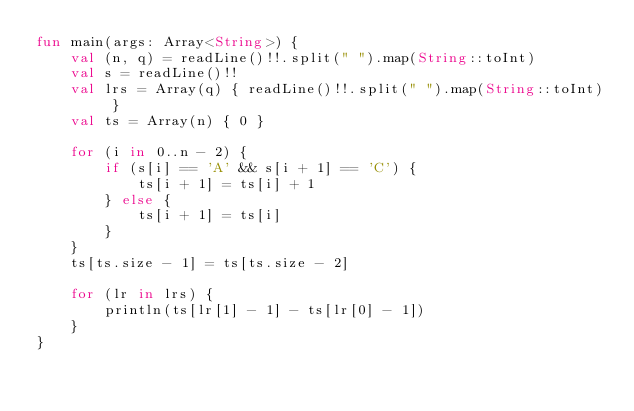Convert code to text. <code><loc_0><loc_0><loc_500><loc_500><_Kotlin_>fun main(args: Array<String>) {
    val (n, q) = readLine()!!.split(" ").map(String::toInt)
    val s = readLine()!!
    val lrs = Array(q) { readLine()!!.split(" ").map(String::toInt) }
    val ts = Array(n) { 0 }

    for (i in 0..n - 2) {
        if (s[i] == 'A' && s[i + 1] == 'C') {
            ts[i + 1] = ts[i] + 1
        } else {
            ts[i + 1] = ts[i]
        }
    }
    ts[ts.size - 1] = ts[ts.size - 2]

    for (lr in lrs) {
        println(ts[lr[1] - 1] - ts[lr[0] - 1])
    }
}
</code> 